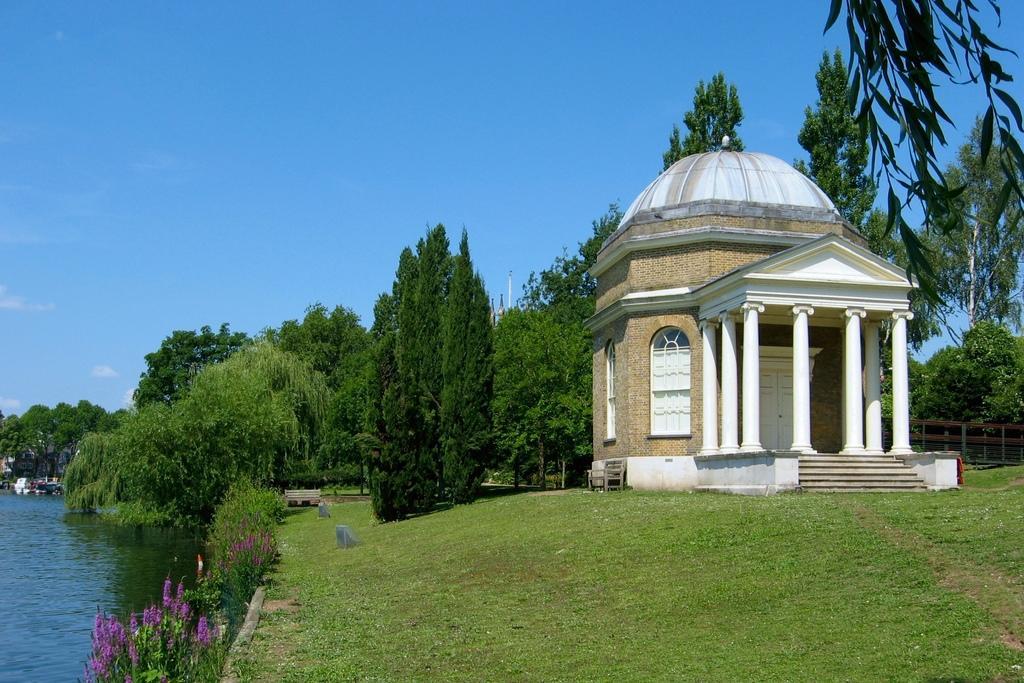Can you describe this image briefly? In this picture there is a building, beside that I can see many trees, plants & grass. In the bottom left corner I can see some flowers on the plants. In the background I can see many trees, poles and buildings. On the left I can see the water/ At the top I can see the sky and clouds. On the left I can see the wooden fencing. In the center there is a bench near to the water. 